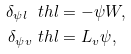Convert formula to latex. <formula><loc_0><loc_0><loc_500><loc_500>\delta _ { \psi l } \ t h l & = - \psi W , \\ \delta _ { \psi v } \ t h l & = L _ { v } \psi ,</formula> 